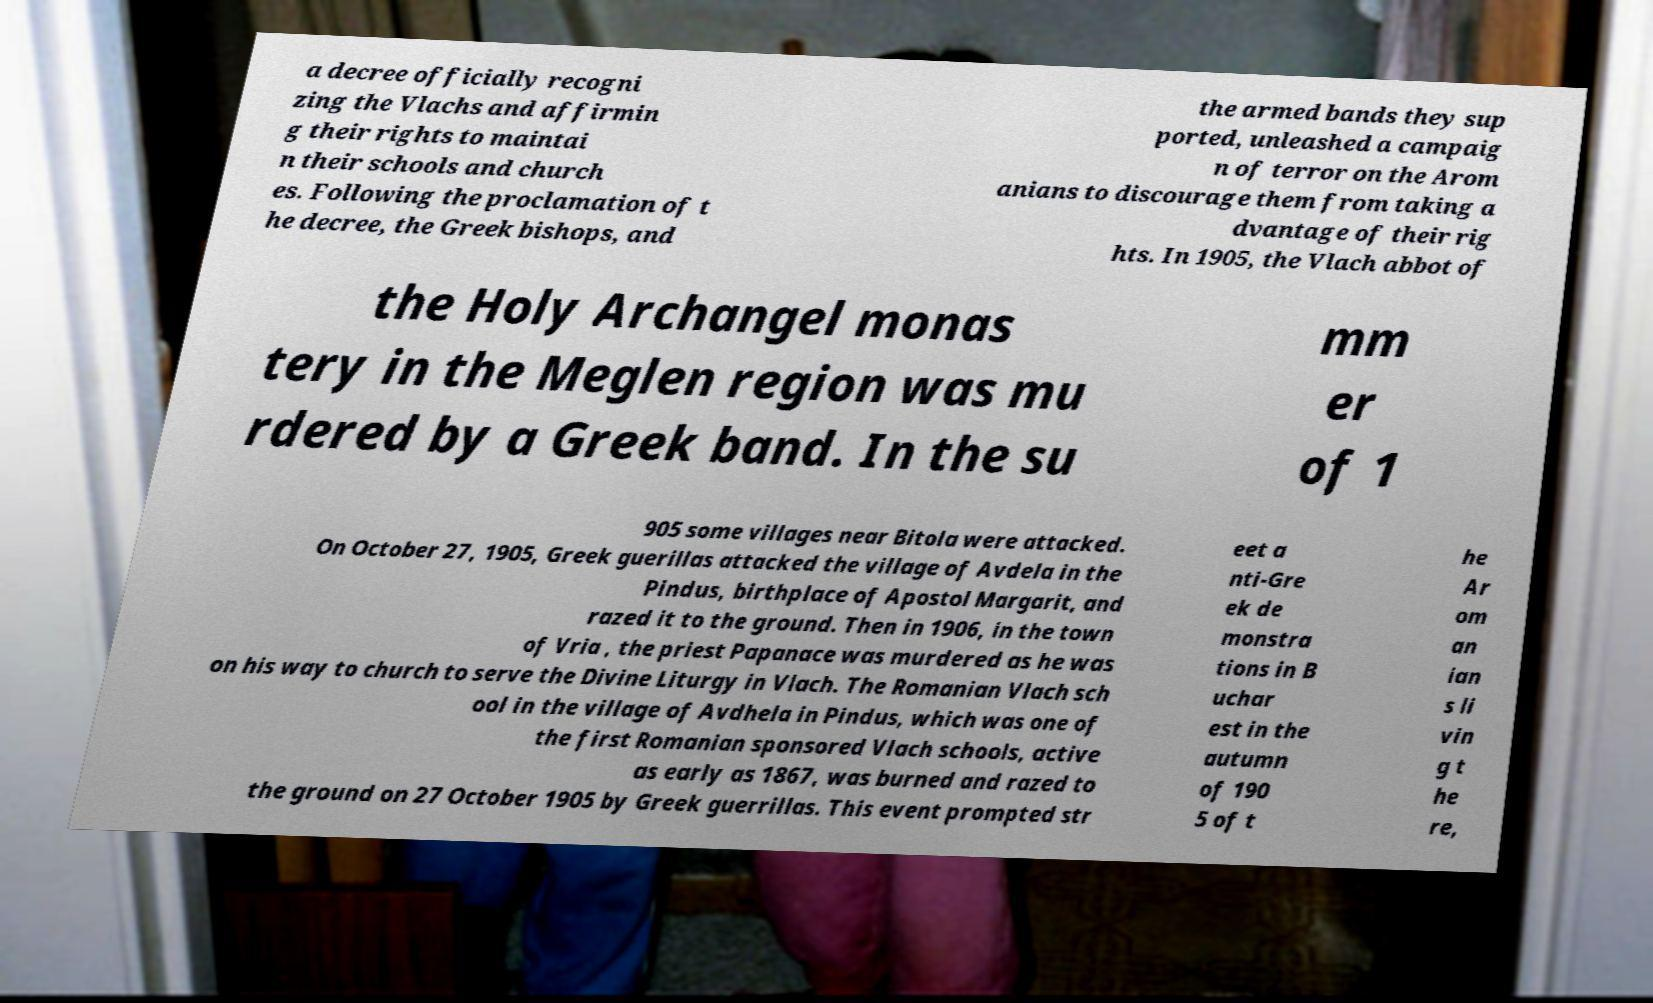For documentation purposes, I need the text within this image transcribed. Could you provide that? a decree officially recogni zing the Vlachs and affirmin g their rights to maintai n their schools and church es. Following the proclamation of t he decree, the Greek bishops, and the armed bands they sup ported, unleashed a campaig n of terror on the Arom anians to discourage them from taking a dvantage of their rig hts. In 1905, the Vlach abbot of the Holy Archangel monas tery in the Meglen region was mu rdered by a Greek band. In the su mm er of 1 905 some villages near Bitola were attacked. On October 27, 1905, Greek guerillas attacked the village of Avdela in the Pindus, birthplace of Apostol Margarit, and razed it to the ground. Then in 1906, in the town of Vria , the priest Papanace was murdered as he was on his way to church to serve the Divine Liturgy in Vlach. The Romanian Vlach sch ool in the village of Avdhela in Pindus, which was one of the first Romanian sponsored Vlach schools, active as early as 1867, was burned and razed to the ground on 27 October 1905 by Greek guerrillas. This event prompted str eet a nti-Gre ek de monstra tions in B uchar est in the autumn of 190 5 of t he Ar om an ian s li vin g t he re, 